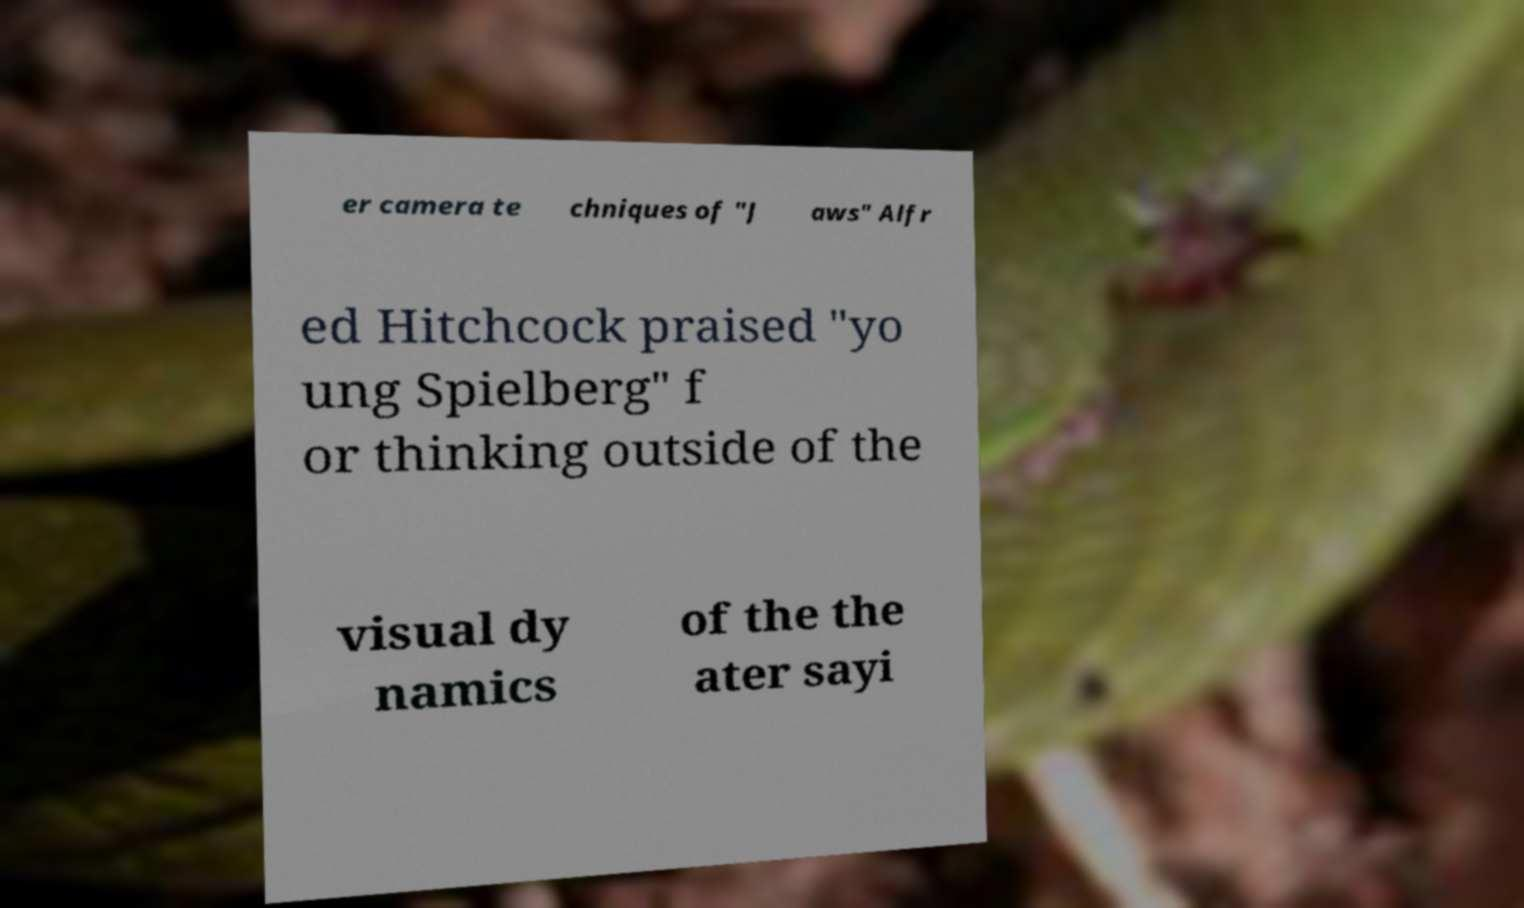I need the written content from this picture converted into text. Can you do that? er camera te chniques of "J aws" Alfr ed Hitchcock praised "yo ung Spielberg" f or thinking outside of the visual dy namics of the the ater sayi 